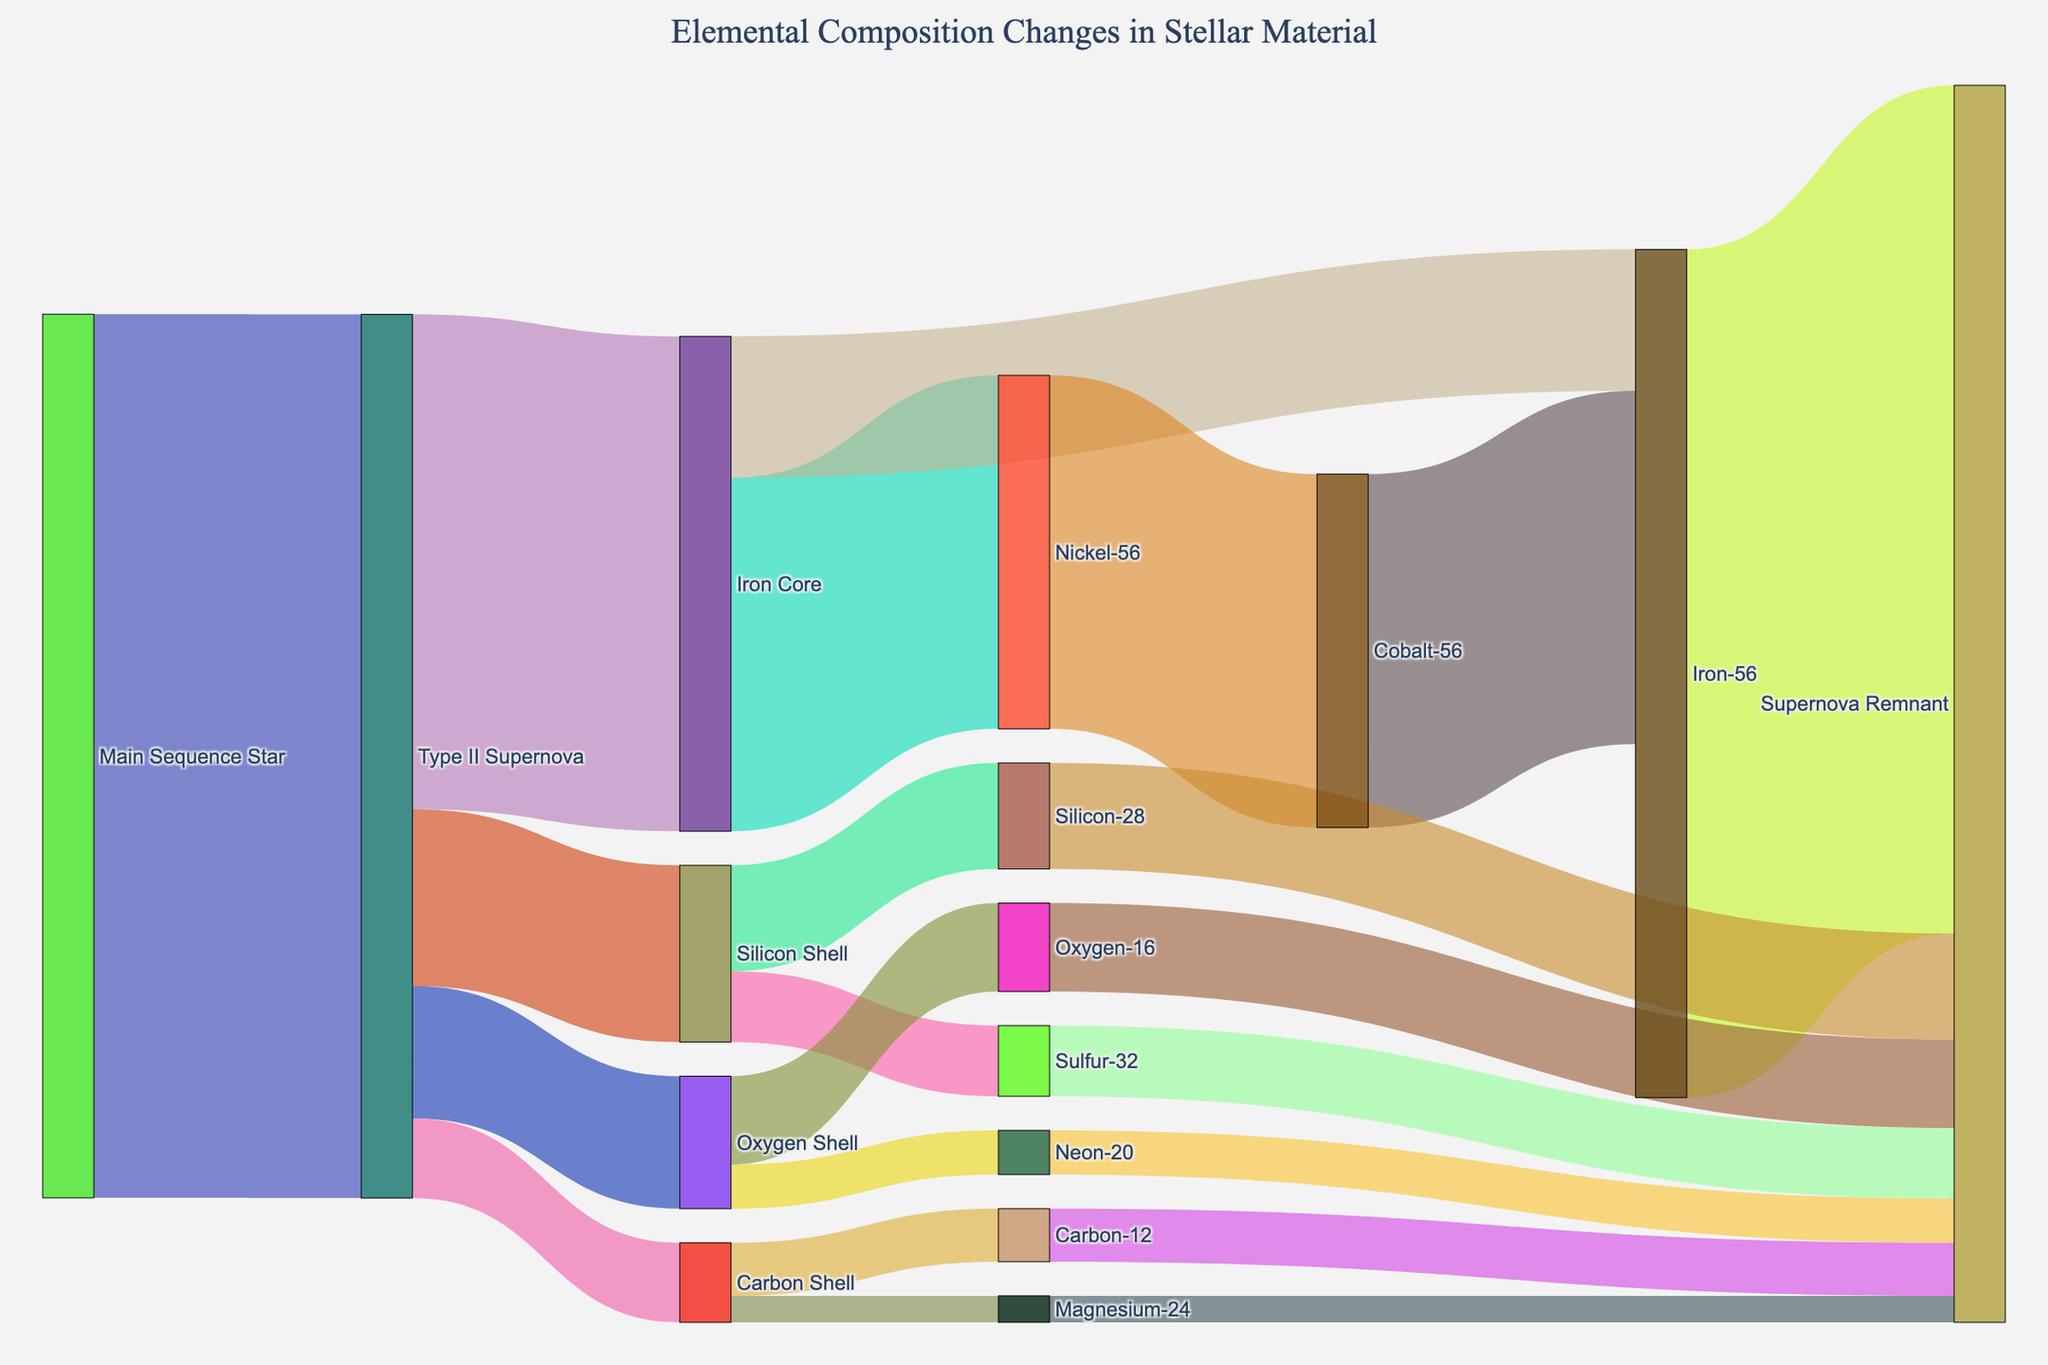What is the title of the Sankey Diagram? The title of the plot is typically found at the top of the figure, detailing its main subject. Here, it specifies the changes in elemental composition during a supernova.
Answer: Elemental Composition Changes in Stellar Material How many distinct elemental changes are traced from the "Type II Supernova"? From the figure, observe the number of links starting from "Type II Supernova" that go to different targets. This would show all traced elemental changes.
Answer: 4 Which element contributes the highest value to the "Supernova Remnant" from the "Iron Core"? From the "Iron Core" node, follow the links to the supernova remnant. Compare the values to identify the highest one.
Answer: Iron-56 How much total value is contributed to the Supernova Remnant from the Silicon Shell and Oxygen Shell combined? Sum the values of links from the "Silicon Shell" and "Oxygen Shell" going to the "Supernova Remnant". Silicon-28 (12) + Sulfur-32 (8) + Oxygen-16 (10) + Neon-20 (5) = 35
Answer: 35 Between Nickel-56 and Carbon-12, which has a higher value that eventually becomes part of the Supernova Remnant? Compare the value starting from "Nickel-56" and "Carbon-12" that becomes part of the "Supernova Remnant". Nickel-56 has 40, and Carbon-12 has 6.
Answer: Nickel-56 What are the values associated with the transformation from Nickel-56 to Cobalt-56, and subsequently from Cobalt-56 to Iron-56? Identify the links between Nickel-56 to Cobalt-56 and from Cobalt-56 to Iron-56. Both transformations have values of 40, so confirm that the process is sequential and equal.
Answer: 40, 40 How does the quantity of Oxygen-16 compare to Neon-20 in the Supernova Remnant? Check the values that migrate from the "Oxygen Shell" to the "Supernova Remnant" for Oxygen-16 and Neon-20. Oxygen-16 is 10 and Neon-20 is 5.
Answer: Oxygen-16 is higher, 10 compared to 5 What percentage of the "Iron Core" ends up as Iron-56 in the Supernova Remnant? Calculate the percentage by dividing the Iron-56 value by the Iron Core total and then multiply by 100. (Iron-56 from remnant is 96, Iron Core value is 56; (96/56)*100 = 171.43%)
Answer: 171.43% From the "Main Sequence Star", describe the flow of materials leading to the Supernova Remnant. Follow the process from the initial stage "Main Sequence Star" to the final "Supernova Remnant". It goes Main Sequence Star -> Type II Supernova -> specific shells and cores -> elemental transformations -> final supernova remnant compositions.
Answer: Sequential conversion through multiple stages Which shell from the "Type II Supernova" contributes the least to the "Supernova Remnant"? Compare the values of each shell (Silicon Shell, Oxygen Shell, Carbon Shell) that ends up as part of the "Supernova Remnant". Carbon Shell with Carbon-12 (6) and Magnesium-24 (3) total 9.
Answer: Carbon Shell (9) 